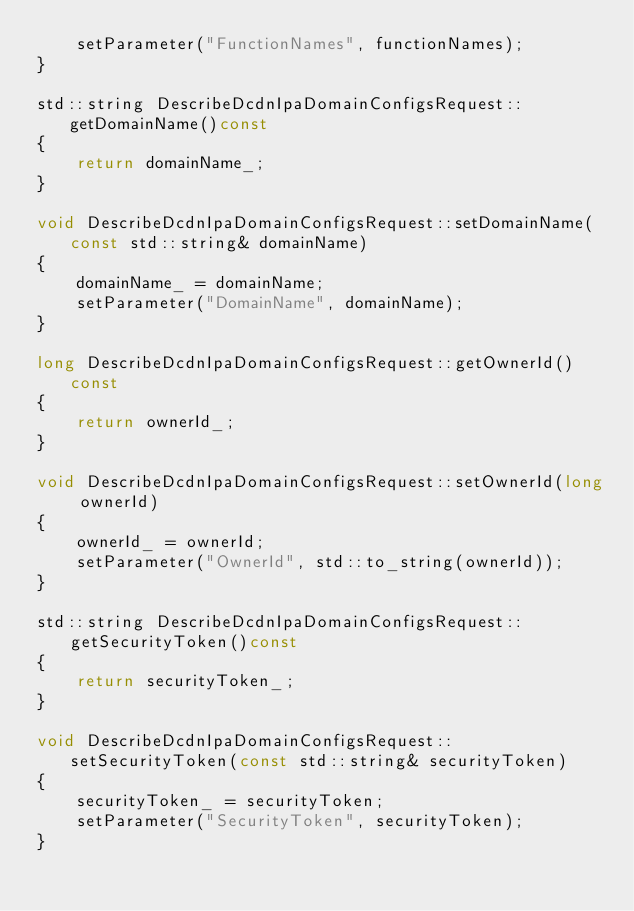Convert code to text. <code><loc_0><loc_0><loc_500><loc_500><_C++_>	setParameter("FunctionNames", functionNames);
}

std::string DescribeDcdnIpaDomainConfigsRequest::getDomainName()const
{
	return domainName_;
}

void DescribeDcdnIpaDomainConfigsRequest::setDomainName(const std::string& domainName)
{
	domainName_ = domainName;
	setParameter("DomainName", domainName);
}

long DescribeDcdnIpaDomainConfigsRequest::getOwnerId()const
{
	return ownerId_;
}

void DescribeDcdnIpaDomainConfigsRequest::setOwnerId(long ownerId)
{
	ownerId_ = ownerId;
	setParameter("OwnerId", std::to_string(ownerId));
}

std::string DescribeDcdnIpaDomainConfigsRequest::getSecurityToken()const
{
	return securityToken_;
}

void DescribeDcdnIpaDomainConfigsRequest::setSecurityToken(const std::string& securityToken)
{
	securityToken_ = securityToken;
	setParameter("SecurityToken", securityToken);
}

</code> 